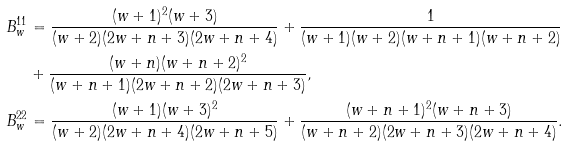<formula> <loc_0><loc_0><loc_500><loc_500>B _ { w } ^ { 1 1 } & = \frac { ( w + 1 ) ^ { 2 } ( w + 3 ) } { ( w + 2 ) ( 2 w + n + 3 ) ( 2 w + n + 4 ) } + \frac { 1 } { ( w + 1 ) ( w + 2 ) ( w + n + 1 ) ( w + n + 2 ) } \\ & + \frac { ( w + n ) ( w + n + 2 ) ^ { 2 } } { ( w + n + 1 ) ( 2 w + n + 2 ) ( 2 w + n + 3 ) } , \\ B _ { w } ^ { 2 2 } & = \frac { ( w + 1 ) ( w + 3 ) ^ { 2 } } { ( w + 2 ) ( 2 w + n + 4 ) ( 2 w + n + 5 ) } + \frac { ( w + n + 1 ) ^ { 2 } ( w + n + 3 ) } { ( w + n + 2 ) ( 2 w + n + 3 ) ( 2 w + n + 4 ) } .</formula> 